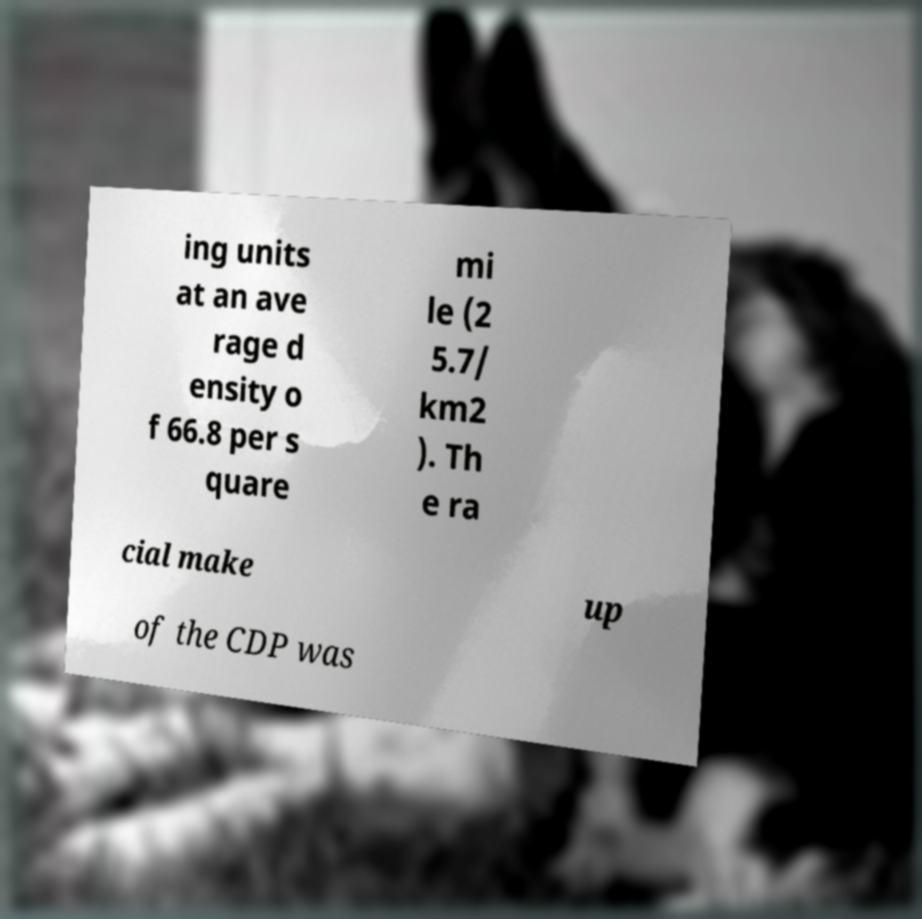Could you extract and type out the text from this image? ing units at an ave rage d ensity o f 66.8 per s quare mi le (2 5.7/ km2 ). Th e ra cial make up of the CDP was 